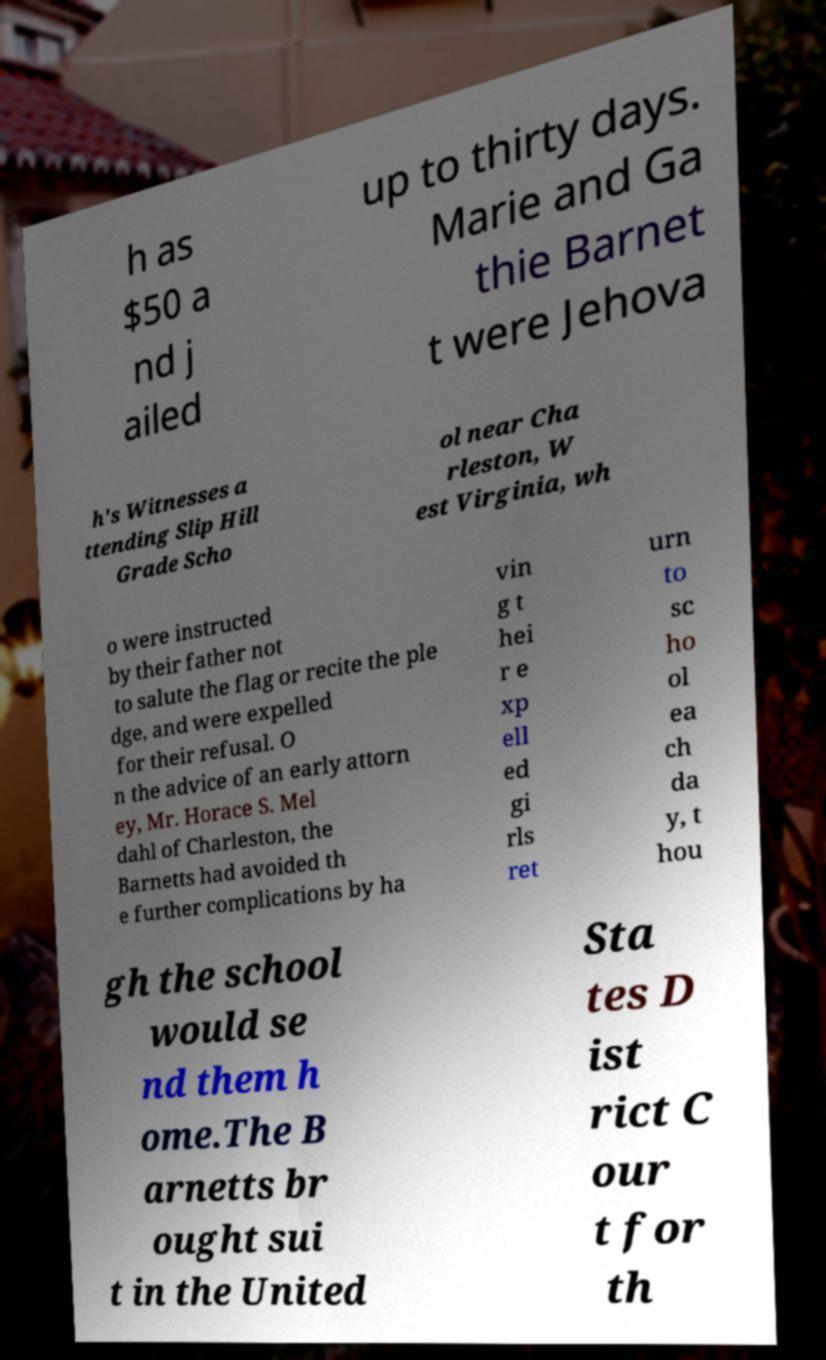What messages or text are displayed in this image? I need them in a readable, typed format. h as $50 a nd j ailed up to thirty days. Marie and Ga thie Barnet t were Jehova h's Witnesses a ttending Slip Hill Grade Scho ol near Cha rleston, W est Virginia, wh o were instructed by their father not to salute the flag or recite the ple dge, and were expelled for their refusal. O n the advice of an early attorn ey, Mr. Horace S. Mel dahl of Charleston, the Barnetts had avoided th e further complications by ha vin g t hei r e xp ell ed gi rls ret urn to sc ho ol ea ch da y, t hou gh the school would se nd them h ome.The B arnetts br ought sui t in the United Sta tes D ist rict C our t for th 